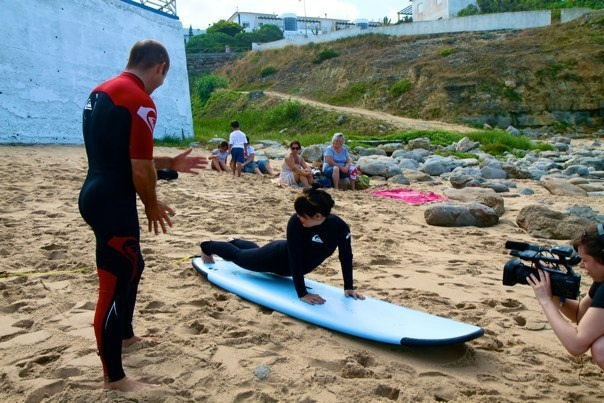Describe the objects in this image and their specific colors. I can see people in lightblue, black, maroon, gray, and brown tones, surfboard in lightblue and black tones, people in lightblue, black, gray, navy, and maroon tones, people in lightblue, black, gray, and maroon tones, and people in lightblue, gray, black, and maroon tones in this image. 